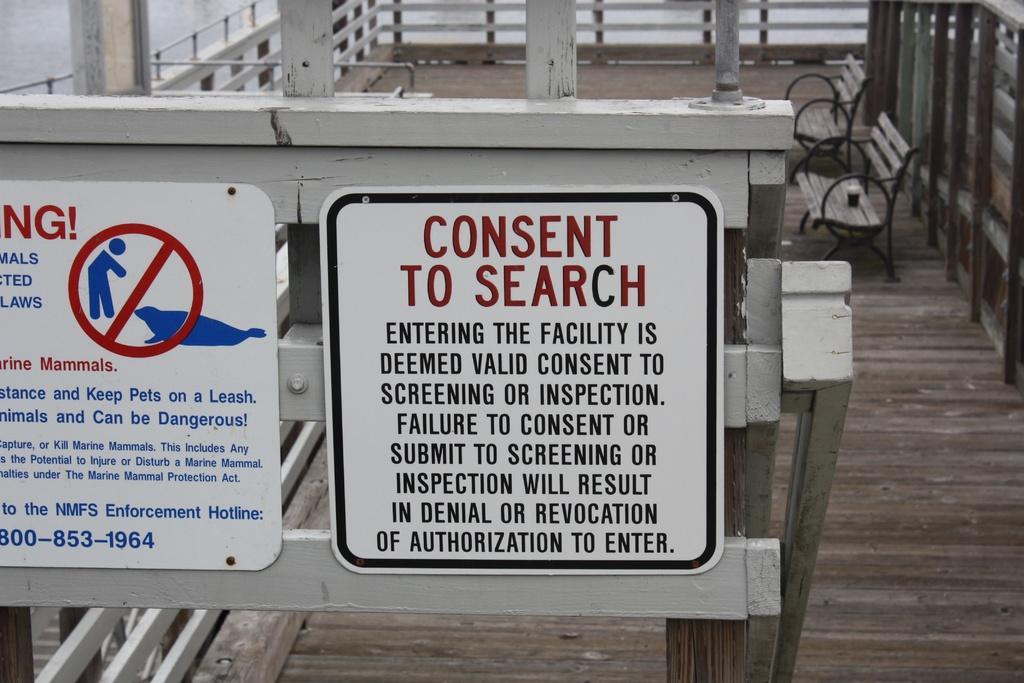In one or two sentences, can you explain what this image depicts? In the foreground of this image, there are two boards to the wooden railing like an object. In the background, there are two benches on the right on a wooden surface and we can also see the wooden railing in the background and on the top left, there is water. 